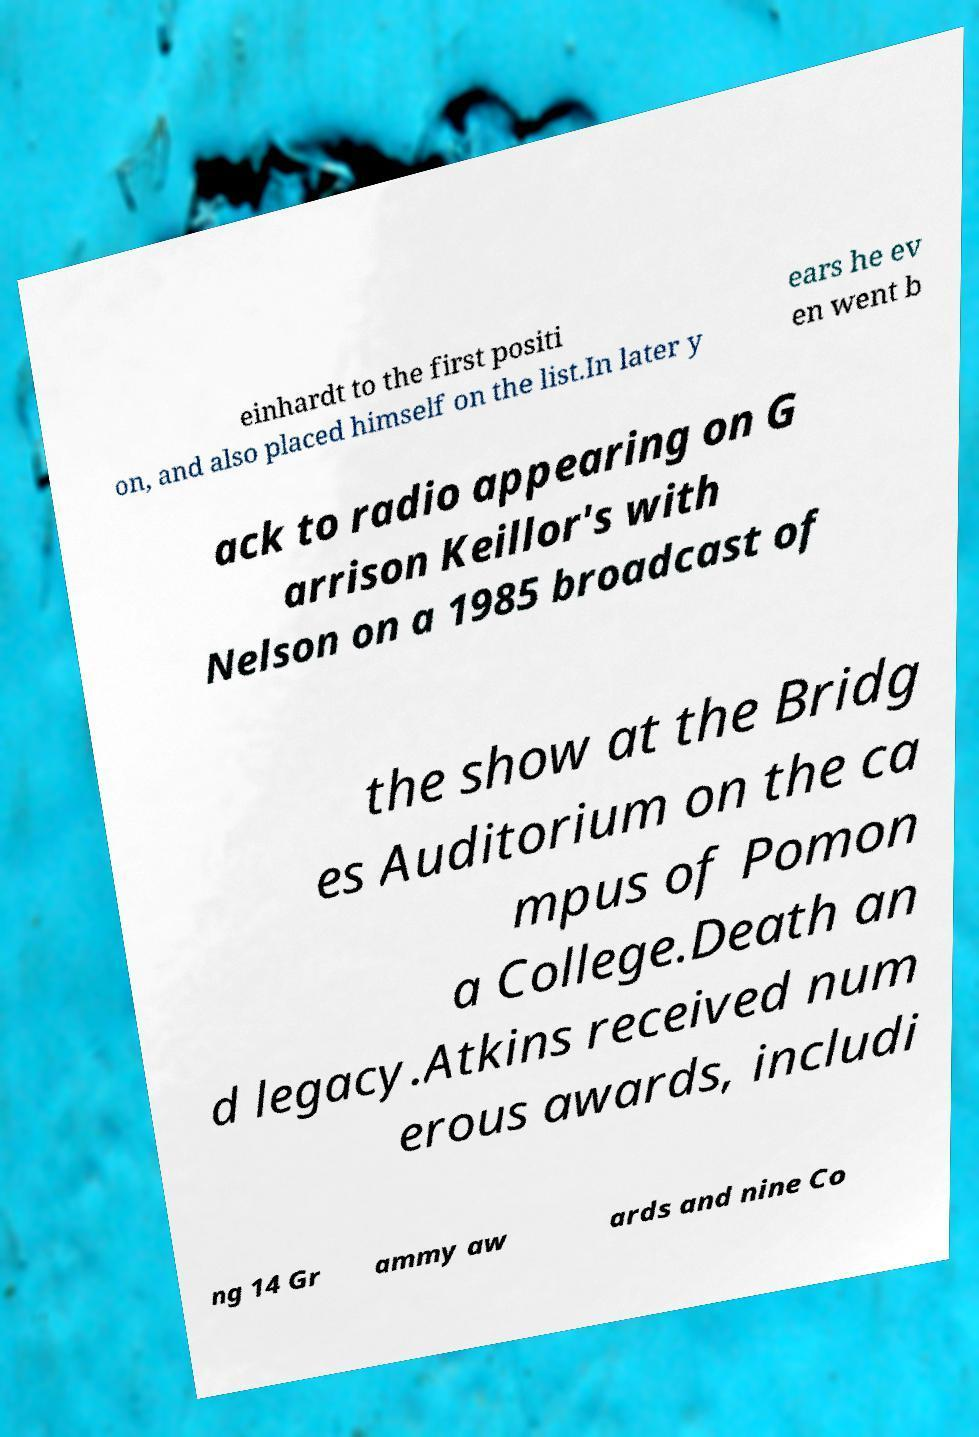For documentation purposes, I need the text within this image transcribed. Could you provide that? einhardt to the first positi on, and also placed himself on the list.In later y ears he ev en went b ack to radio appearing on G arrison Keillor's with Nelson on a 1985 broadcast of the show at the Bridg es Auditorium on the ca mpus of Pomon a College.Death an d legacy.Atkins received num erous awards, includi ng 14 Gr ammy aw ards and nine Co 